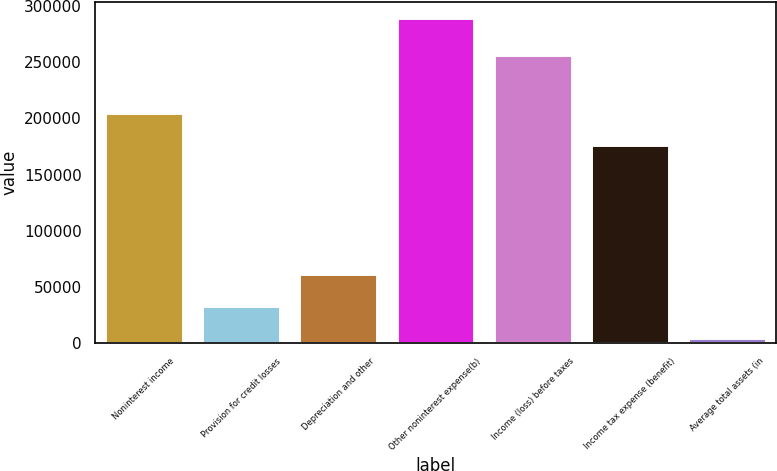Convert chart. <chart><loc_0><loc_0><loc_500><loc_500><bar_chart><fcel>Noninterest income<fcel>Provision for credit losses<fcel>Depreciation and other<fcel>Other noninterest expense(b)<fcel>Income (loss) before taxes<fcel>Income tax expense (benefit)<fcel>Average total assets (in<nl><fcel>204736<fcel>33431.2<fcel>61864.4<fcel>289330<fcel>256124<fcel>176303<fcel>4998<nl></chart> 